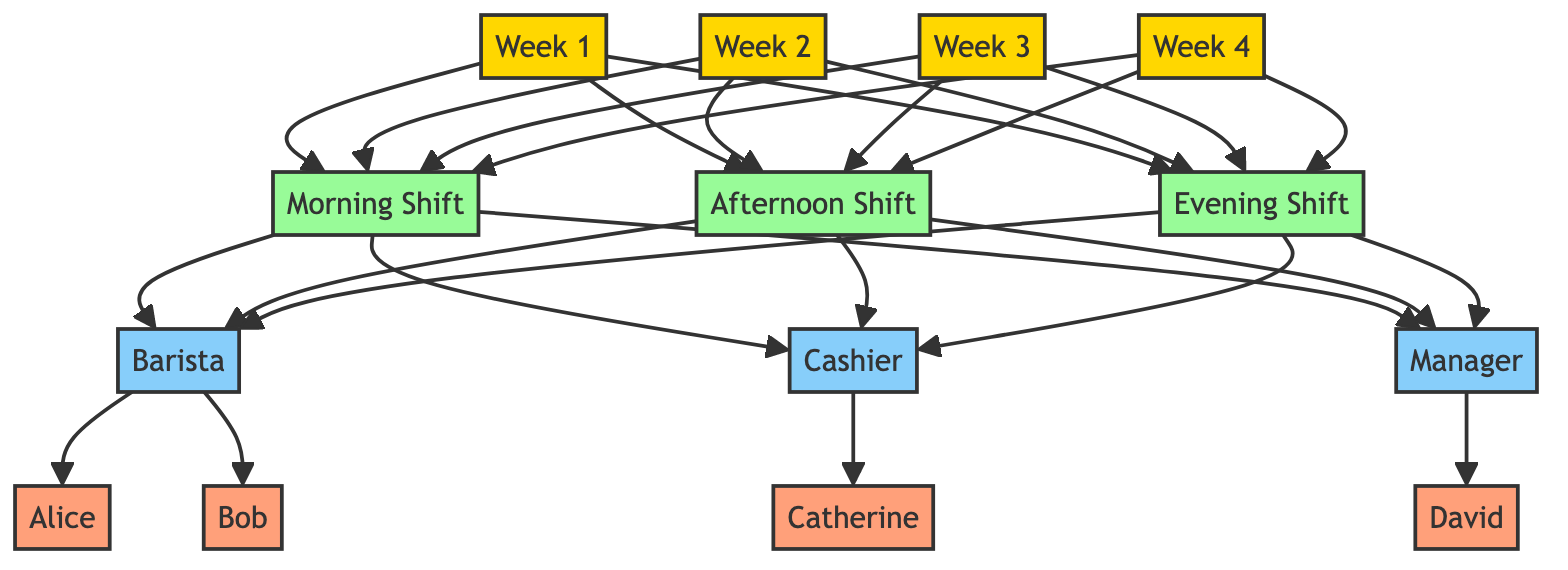What are the three shifts in the schedule? The diagram shows three shifts labeled as Morning Shift, Afternoon Shift, and Evening Shift. Each shift is connected to all four weeks, indicating that these shifts occur weekly.
Answer: Morning Shift, Afternoon Shift, Evening Shift How many employees are assigned to different roles? The diagram lists four employees: Alice, Bob, Catherine, and David. Each of these employees is assigned to a specific role within the shifts specified.
Answer: Four employees Who is assigned as the Manager? In the diagram, the role labeled Manager is specifically connected to the fourth week, which indicates that there is a designated individual for this role.
Answer: David Which week does Bob work? The information indicates that Bob is specifically assigned to the second week under the shifts defined. We can locate his name associated with the second week node in the diagram.
Answer: Week 2 How many weeks are represented in the diagram? The diagram clearly labels four distinct weeks (Week 1, Week 2, Week 3, Week 4), showing a timeline structure that covers one month.
Answer: Four weeks Which roles are available each week? The diagram indicates that each week (Week 1 to Week 4) provides the roles of Barista, Cashier, and Manager. Each of these roles is available for each of the four weeks.
Answer: Barista, Cashier, Manager How many shifts occur in total over the month? The diagram shows three shifts that are listed under each of the four weeks providing a total of three shifts per week. Thus, to find the total, we multiply the number of weeks (4) by the number of shifts (3).
Answer: Twelve shifts Which employee works as a Barista? According to the diagram, during the weeks assigned, Alice and Bob are specifically shown to work as Baristas. By referencing the roles connected to the employees, we can deduce who has this title.
Answer: Alice, Bob What is the color representing employee nodes in the diagram? In the diagram, the employees such as Alice, Bob, Catherine, and David are represented by orange nodes, indicating their role as employees under the shift schedule.
Answer: Orange 